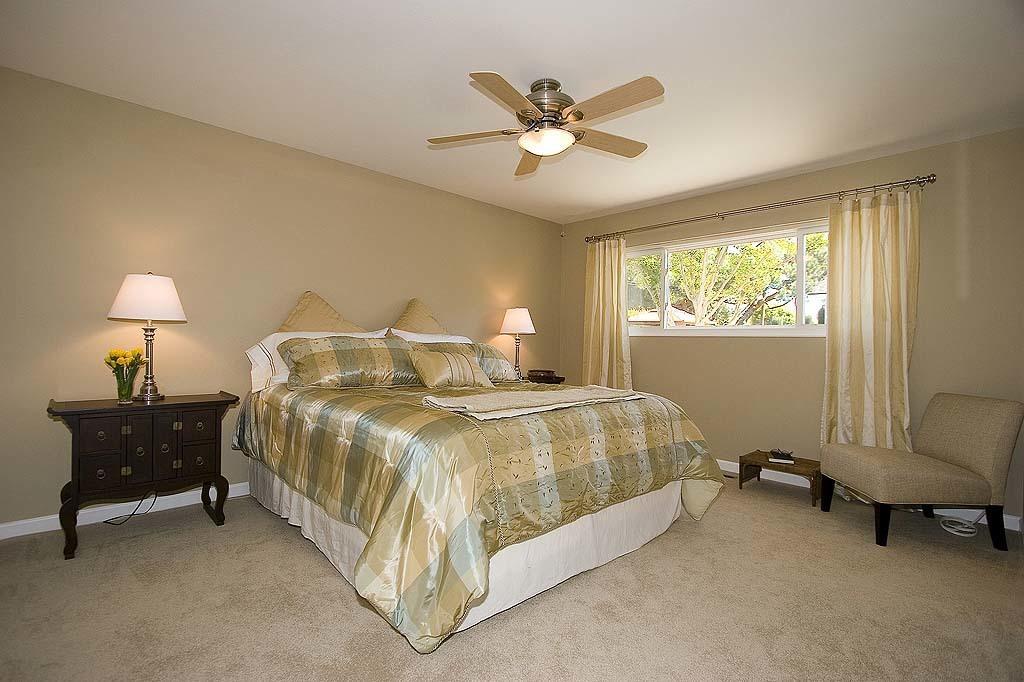Describe this image in one or two sentences. There is a bed with bed sheet and pillows. Near to that there are tables. On the tables there is table lamp. Also there is a vase with flowers. On the ceiling there is a fan with light. There are windows with curtains. Through the window we can see trees. 